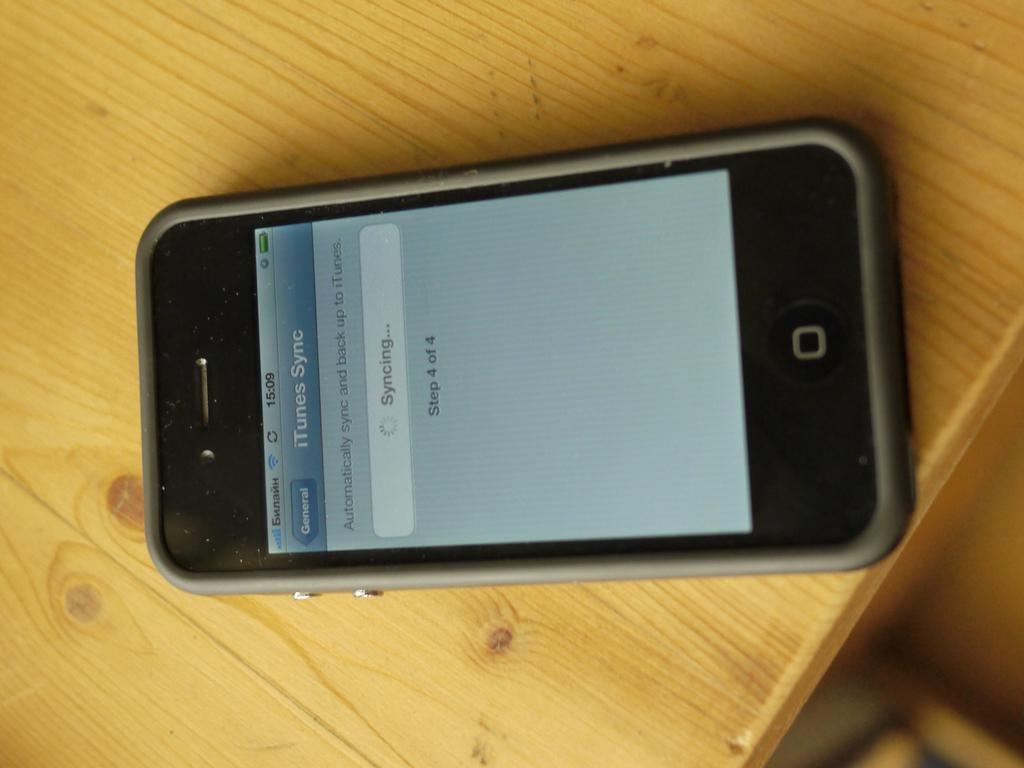<image>
Create a compact narrative representing the image presented. An electronic device open to a page that says ITunes sync. 